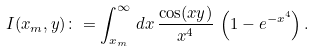<formula> <loc_0><loc_0><loc_500><loc_500>I ( x _ { m } , y ) \colon = \int _ { x _ { m } } ^ { \infty } \, d x \, \frac { \cos ( x y ) } { x ^ { 4 } } \, \left ( 1 - e ^ { - x ^ { 4 } } \right ) .</formula> 